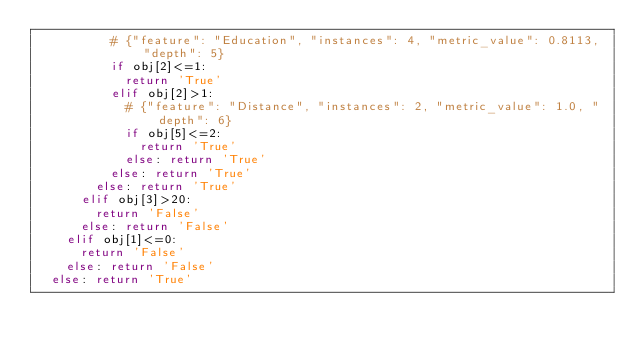<code> <loc_0><loc_0><loc_500><loc_500><_Python_>					# {"feature": "Education", "instances": 4, "metric_value": 0.8113, "depth": 5}
					if obj[2]<=1:
						return 'True'
					elif obj[2]>1:
						# {"feature": "Distance", "instances": 2, "metric_value": 1.0, "depth": 6}
						if obj[5]<=2:
							return 'True'
						else: return 'True'
					else: return 'True'
				else: return 'True'
			elif obj[3]>20:
				return 'False'
			else: return 'False'
		elif obj[1]<=0:
			return 'False'
		else: return 'False'
	else: return 'True'
</code> 